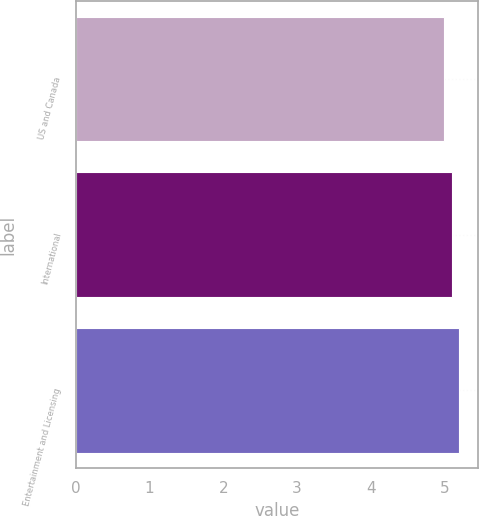<chart> <loc_0><loc_0><loc_500><loc_500><bar_chart><fcel>US and Canada<fcel>International<fcel>Entertainment and Licensing<nl><fcel>5<fcel>5.1<fcel>5.2<nl></chart> 